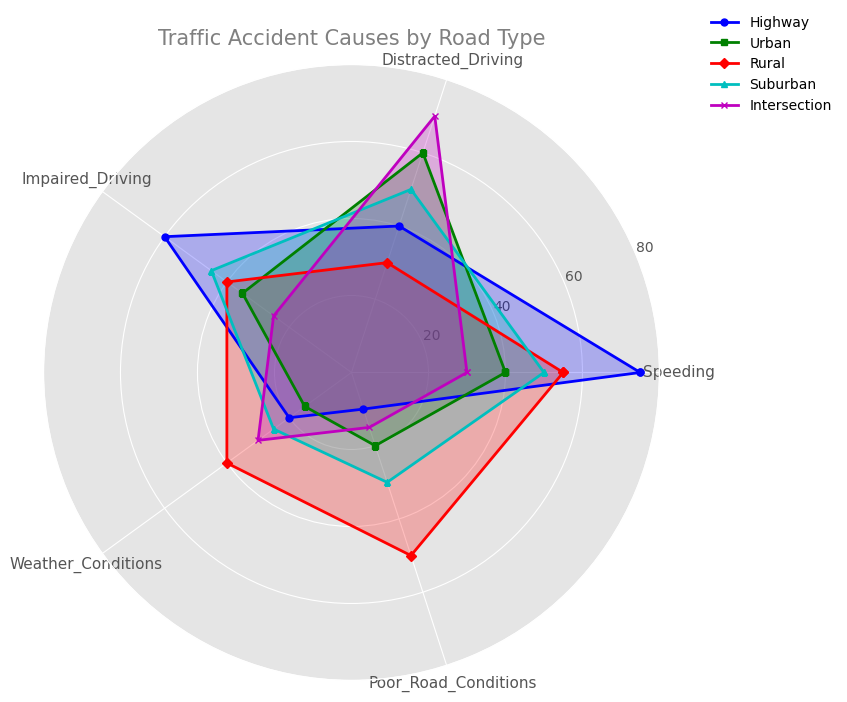What's the predominant cause of traffic accidents at Intersections? To determine the predominant cause, look for the category with the largest value in the 'Intersection' data. The highest point reached is for Distracted Driving.
Answer: Distracted Driving Which road type has the highest incidence of traffic accidents due to Poor Road Conditions? Scan the points corresponding to Poor Road Conditions across all the road types. The highest point is in the Rural category.
Answer: Rural Is Speeding more frequent on Highways or in Urban areas? Compare the points for Speeding between Highways and Urban. The point for Highways (75) is higher than for Urban (40).
Answer: Highways What is the average percentage of accidents caused by Weather Conditions, Poor Road Conditions, and Impaired Driving in Suburban areas? Add the values: Weather Conditions (25), Poor Road Conditions (30), and Impaired Driving (45). Divide by the number of causes (3). (25 + 30 + 45) / 3 = 100 / 3 = 33.33
Answer: 33.33 What are the main causes of traffic accidents in Rural areas? Look at the values for all causes in the Rural category. The main causes have higher values: Poor Road Conditions (50), Weather Conditions (40), Speeding (55).
Answer: Poor Road Conditions, Weather Conditions, Speeding Which road type has the least number of accidents caused by Impaired Driving? Compare the points for Impaired Driving across all road types. The lowest point is for Intersection (25).
Answer: Intersection Between Urban and Suburban areas, which has a higher incidence of accidents due to Distracted Driving? Compare the values for Distracted Driving between Urban (60) and Suburban (50). Urban has a higher value.
Answer: Urban How does Weather Conditions' impact on traffic accidents compare between Highways and Rural areas? Compare the values for Weather Conditions between Highways (20) and Rural (40). Rural has a higher value.
Answer: Rural What is the combined impact of Speeding and Poor Road Conditions on accidents in Highways? Add the values for Speeding (75) and Poor Road Conditions (10). 75 + 10 = 85
Answer: 85 How do Poor Road Conditions contribute to accidents in Urban compared to Suburban areas? Compare the values for Poor Road Conditions in Urban (20) and Suburban (30). Suburban has a higher value.
Answer: Suburban 